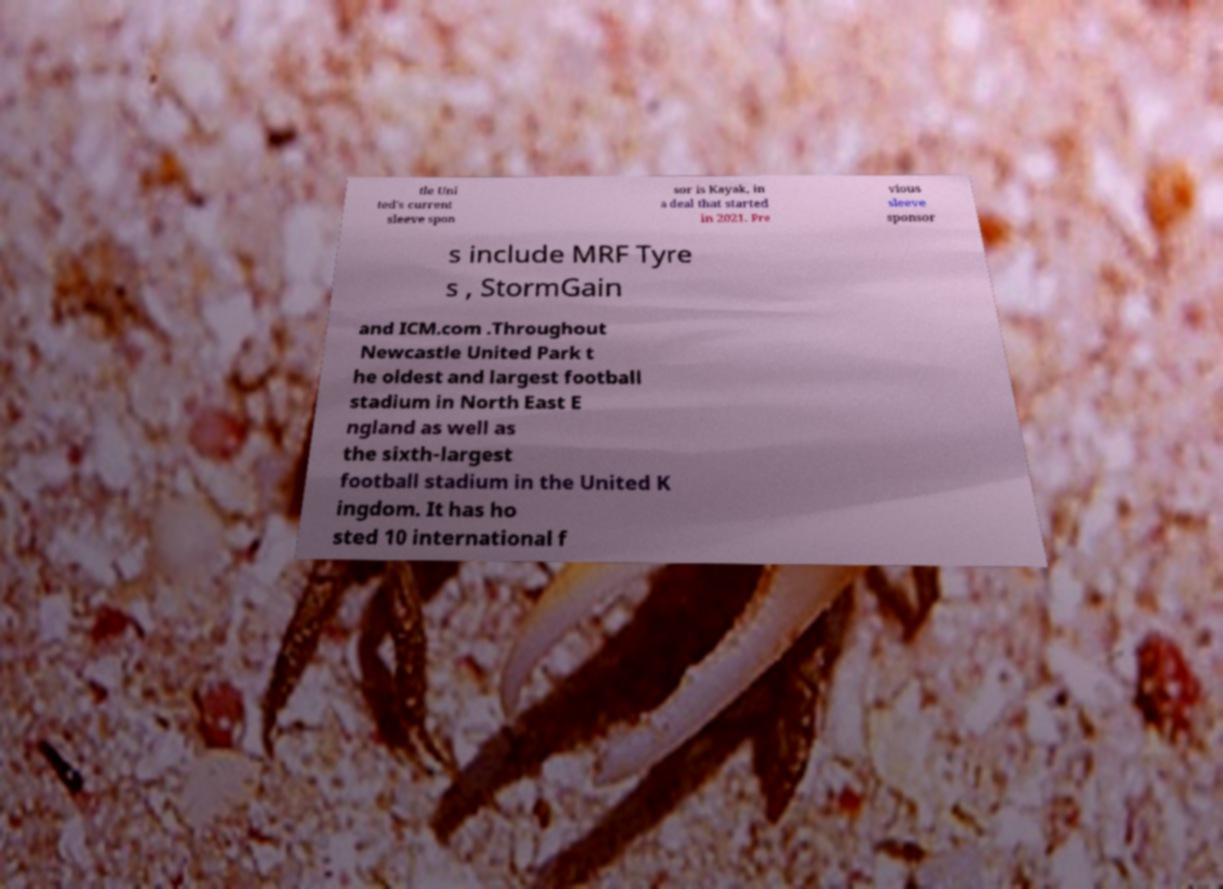Can you accurately transcribe the text from the provided image for me? tle Uni ted's current sleeve spon sor is Kayak, in a deal that started in 2021. Pre vious sleeve sponsor s include MRF Tyre s , StormGain and ICM.com .Throughout Newcastle United Park t he oldest and largest football stadium in North East E ngland as well as the sixth-largest football stadium in the United K ingdom. It has ho sted 10 international f 